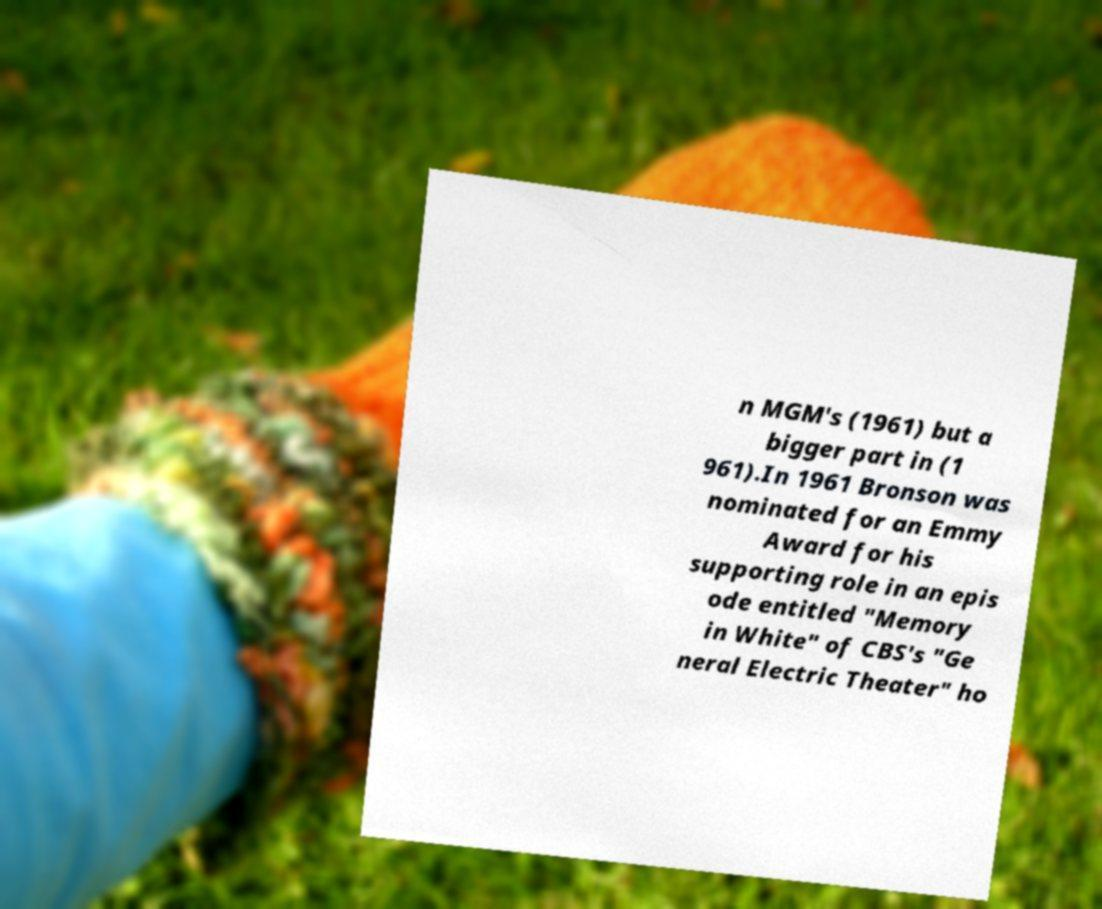Please read and relay the text visible in this image. What does it say? n MGM's (1961) but a bigger part in (1 961).In 1961 Bronson was nominated for an Emmy Award for his supporting role in an epis ode entitled "Memory in White" of CBS's "Ge neral Electric Theater" ho 